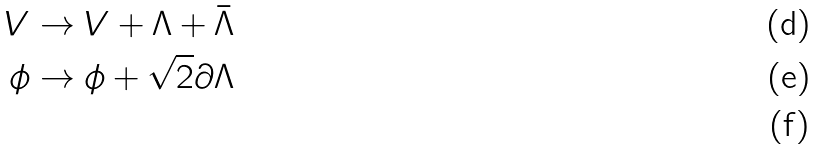<formula> <loc_0><loc_0><loc_500><loc_500>V & \rightarrow V + \Lambda + \bar { \Lambda } \\ \phi & \rightarrow \phi + \sqrt { 2 } \partial \Lambda \\</formula> 